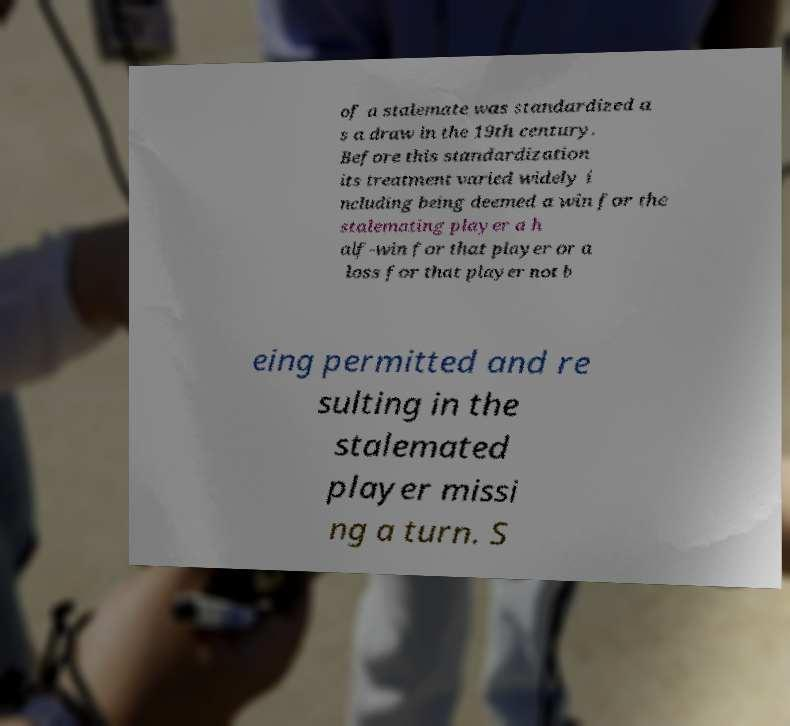Can you read and provide the text displayed in the image?This photo seems to have some interesting text. Can you extract and type it out for me? of a stalemate was standardized a s a draw in the 19th century. Before this standardization its treatment varied widely i ncluding being deemed a win for the stalemating player a h alf-win for that player or a loss for that player not b eing permitted and re sulting in the stalemated player missi ng a turn. S 